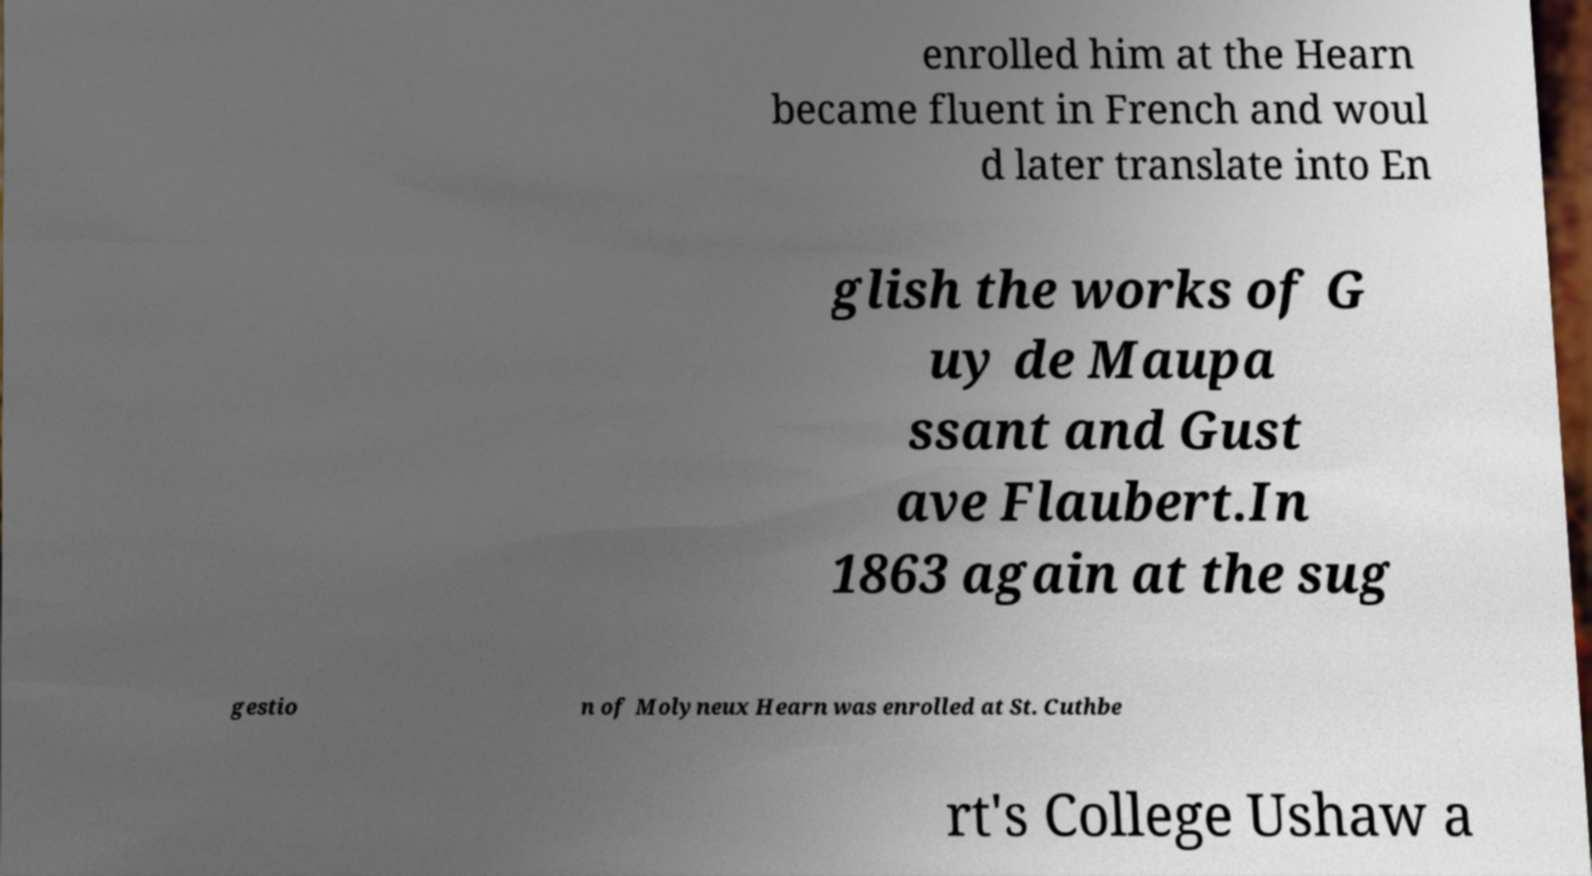Can you accurately transcribe the text from the provided image for me? enrolled him at the Hearn became fluent in French and woul d later translate into En glish the works of G uy de Maupa ssant and Gust ave Flaubert.In 1863 again at the sug gestio n of Molyneux Hearn was enrolled at St. Cuthbe rt's College Ushaw a 